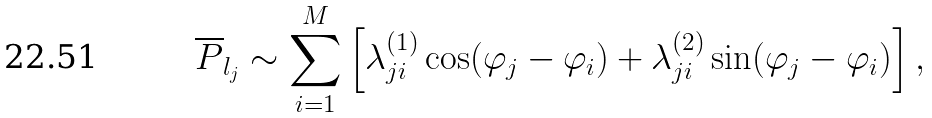Convert formula to latex. <formula><loc_0><loc_0><loc_500><loc_500>\overline { P } _ { l _ { j } } \sim \sum _ { i = 1 } ^ { M } \left [ \lambda ^ { ( 1 ) } _ { j i } \cos ( \varphi _ { j } - \varphi _ { i } ) + \lambda ^ { ( 2 ) } _ { j i } \sin ( \varphi _ { j } - \varphi _ { i } ) \right ] ,</formula> 